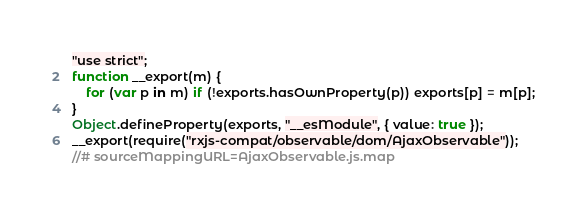Convert code to text. <code><loc_0><loc_0><loc_500><loc_500><_JavaScript_>"use strict";
function __export(m) {
    for (var p in m) if (!exports.hasOwnProperty(p)) exports[p] = m[p];
}
Object.defineProperty(exports, "__esModule", { value: true });
__export(require("rxjs-compat/observable/dom/AjaxObservable"));
//# sourceMappingURL=AjaxObservable.js.map</code> 